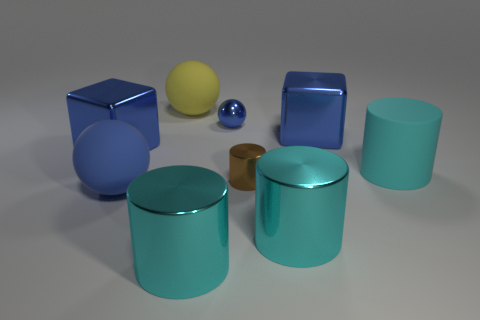Subtract all rubber spheres. How many spheres are left? 1 Subtract all cyan cylinders. How many cylinders are left? 1 Add 1 big cyan matte objects. How many objects exist? 10 Subtract 1 spheres. How many spheres are left? 2 Subtract all balls. How many objects are left? 6 Subtract all red spheres. How many red blocks are left? 0 Subtract all cyan matte cylinders. Subtract all tiny metallic spheres. How many objects are left? 7 Add 6 tiny brown metallic things. How many tiny brown metallic things are left? 7 Add 6 large yellow spheres. How many large yellow spheres exist? 7 Subtract 0 cyan blocks. How many objects are left? 9 